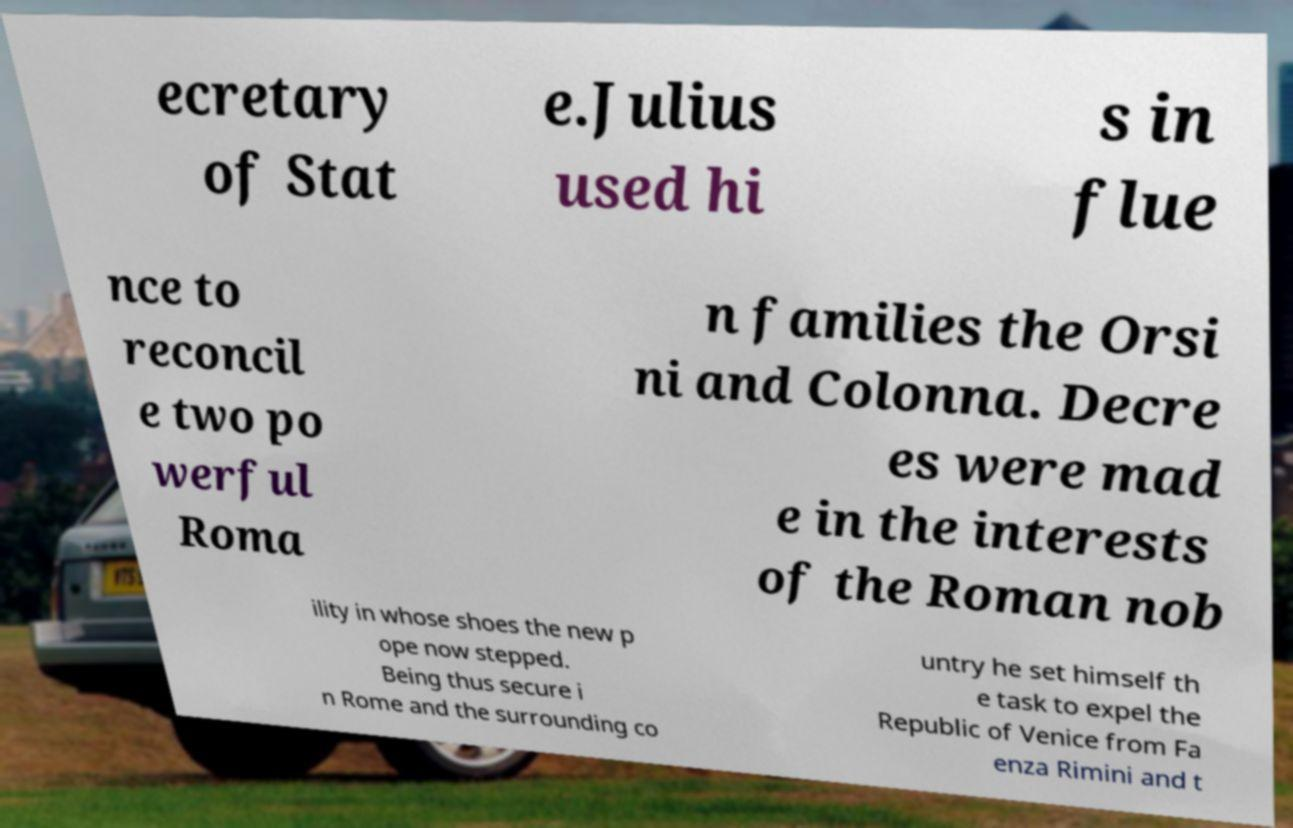For documentation purposes, I need the text within this image transcribed. Could you provide that? ecretary of Stat e.Julius used hi s in flue nce to reconcil e two po werful Roma n families the Orsi ni and Colonna. Decre es were mad e in the interests of the Roman nob ility in whose shoes the new p ope now stepped. Being thus secure i n Rome and the surrounding co untry he set himself th e task to expel the Republic of Venice from Fa enza Rimini and t 